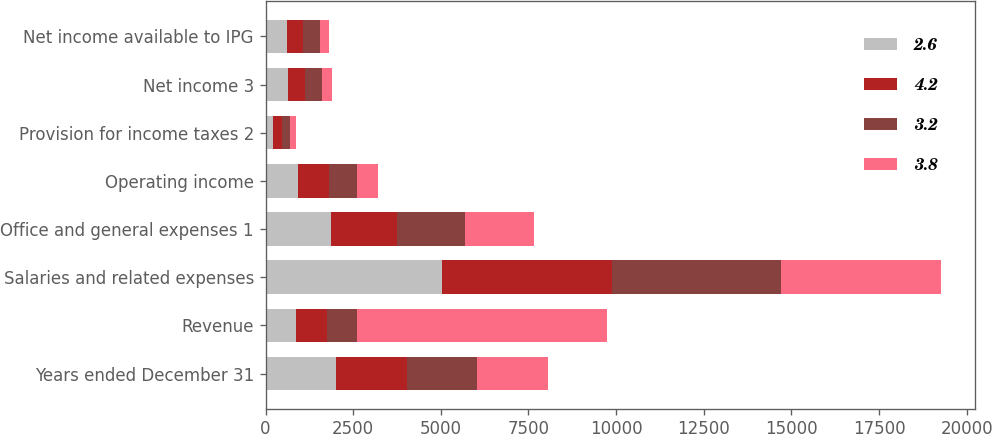<chart> <loc_0><loc_0><loc_500><loc_500><stacked_bar_chart><ecel><fcel>Years ended December 31<fcel>Revenue<fcel>Salaries and related expenses<fcel>Office and general expenses 1<fcel>Operating income<fcel>Provision for income taxes 2<fcel>Net income 3<fcel>Net income available to IPG<nl><fcel>2.6<fcel>2016<fcel>871.9<fcel>5038.1<fcel>1870.5<fcel>938<fcel>198<fcel>632.5<fcel>608.5<nl><fcel>4.2<fcel>2015<fcel>871.9<fcel>4857.7<fcel>1884.2<fcel>871.9<fcel>282.8<fcel>480.5<fcel>454.6<nl><fcel>3.2<fcel>2014<fcel>871.9<fcel>4820.4<fcel>1928.3<fcel>788.4<fcel>216.5<fcel>505.4<fcel>477.1<nl><fcel>3.8<fcel>2013<fcel>7122.3<fcel>4545.5<fcel>1978.5<fcel>598.3<fcel>181.2<fcel>288.9<fcel>259.2<nl></chart> 